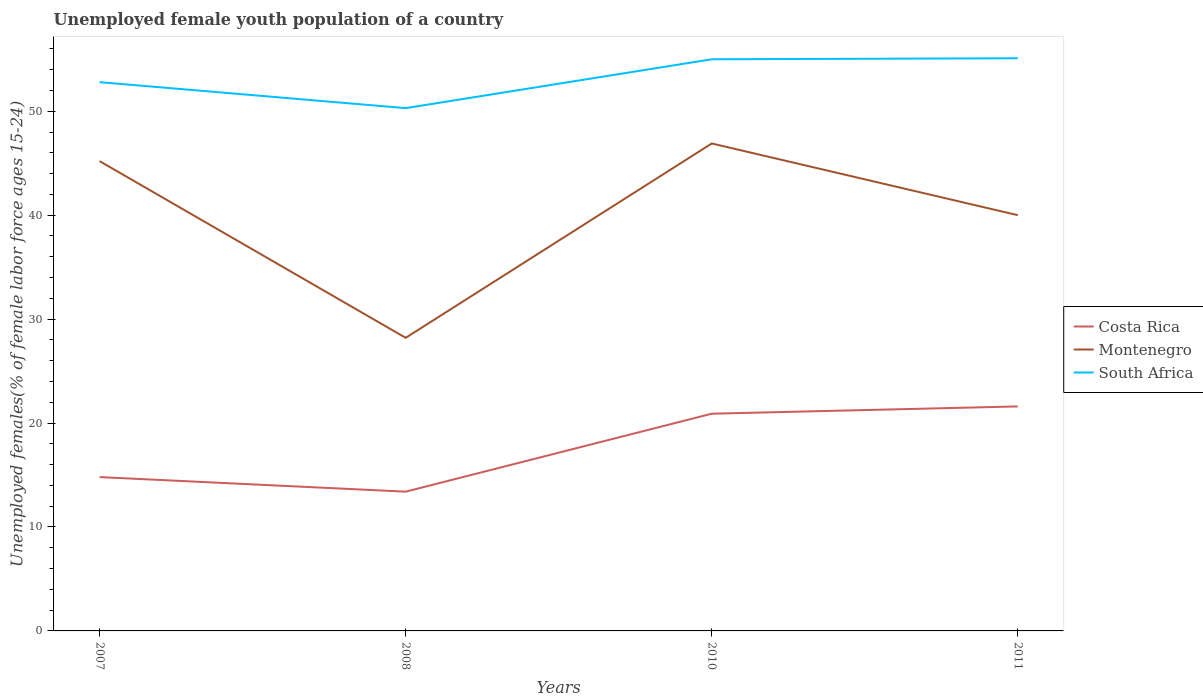Does the line corresponding to Costa Rica intersect with the line corresponding to Montenegro?
Provide a succinct answer. No. Across all years, what is the maximum percentage of unemployed female youth population in South Africa?
Your response must be concise. 50.3. What is the total percentage of unemployed female youth population in Montenegro in the graph?
Offer a terse response. 17. What is the difference between the highest and the second highest percentage of unemployed female youth population in South Africa?
Keep it short and to the point. 4.8. What is the difference between the highest and the lowest percentage of unemployed female youth population in Costa Rica?
Offer a terse response. 2. Is the percentage of unemployed female youth population in Costa Rica strictly greater than the percentage of unemployed female youth population in Montenegro over the years?
Your answer should be very brief. Yes. How many lines are there?
Offer a very short reply. 3. How many years are there in the graph?
Make the answer very short. 4. Does the graph contain any zero values?
Your response must be concise. No. Does the graph contain grids?
Offer a very short reply. No. Where does the legend appear in the graph?
Ensure brevity in your answer.  Center right. What is the title of the graph?
Your answer should be very brief. Unemployed female youth population of a country. What is the label or title of the X-axis?
Offer a terse response. Years. What is the label or title of the Y-axis?
Give a very brief answer. Unemployed females(% of female labor force ages 15-24). What is the Unemployed females(% of female labor force ages 15-24) in Costa Rica in 2007?
Your response must be concise. 14.8. What is the Unemployed females(% of female labor force ages 15-24) of Montenegro in 2007?
Ensure brevity in your answer.  45.2. What is the Unemployed females(% of female labor force ages 15-24) of South Africa in 2007?
Ensure brevity in your answer.  52.8. What is the Unemployed females(% of female labor force ages 15-24) of Costa Rica in 2008?
Ensure brevity in your answer.  13.4. What is the Unemployed females(% of female labor force ages 15-24) in Montenegro in 2008?
Keep it short and to the point. 28.2. What is the Unemployed females(% of female labor force ages 15-24) in South Africa in 2008?
Offer a terse response. 50.3. What is the Unemployed females(% of female labor force ages 15-24) in Costa Rica in 2010?
Offer a terse response. 20.9. What is the Unemployed females(% of female labor force ages 15-24) of Montenegro in 2010?
Offer a terse response. 46.9. What is the Unemployed females(% of female labor force ages 15-24) of South Africa in 2010?
Provide a succinct answer. 55. What is the Unemployed females(% of female labor force ages 15-24) in Costa Rica in 2011?
Provide a short and direct response. 21.6. What is the Unemployed females(% of female labor force ages 15-24) in South Africa in 2011?
Your answer should be compact. 55.1. Across all years, what is the maximum Unemployed females(% of female labor force ages 15-24) of Costa Rica?
Provide a short and direct response. 21.6. Across all years, what is the maximum Unemployed females(% of female labor force ages 15-24) of Montenegro?
Provide a short and direct response. 46.9. Across all years, what is the maximum Unemployed females(% of female labor force ages 15-24) of South Africa?
Provide a succinct answer. 55.1. Across all years, what is the minimum Unemployed females(% of female labor force ages 15-24) in Costa Rica?
Your answer should be very brief. 13.4. Across all years, what is the minimum Unemployed females(% of female labor force ages 15-24) of Montenegro?
Give a very brief answer. 28.2. Across all years, what is the minimum Unemployed females(% of female labor force ages 15-24) of South Africa?
Keep it short and to the point. 50.3. What is the total Unemployed females(% of female labor force ages 15-24) in Costa Rica in the graph?
Offer a terse response. 70.7. What is the total Unemployed females(% of female labor force ages 15-24) in Montenegro in the graph?
Your response must be concise. 160.3. What is the total Unemployed females(% of female labor force ages 15-24) of South Africa in the graph?
Your response must be concise. 213.2. What is the difference between the Unemployed females(% of female labor force ages 15-24) of Costa Rica in 2007 and that in 2008?
Your answer should be very brief. 1.4. What is the difference between the Unemployed females(% of female labor force ages 15-24) of Montenegro in 2007 and that in 2008?
Keep it short and to the point. 17. What is the difference between the Unemployed females(% of female labor force ages 15-24) in Montenegro in 2007 and that in 2010?
Provide a short and direct response. -1.7. What is the difference between the Unemployed females(% of female labor force ages 15-24) of South Africa in 2007 and that in 2010?
Offer a terse response. -2.2. What is the difference between the Unemployed females(% of female labor force ages 15-24) of Costa Rica in 2007 and that in 2011?
Your response must be concise. -6.8. What is the difference between the Unemployed females(% of female labor force ages 15-24) of Montenegro in 2007 and that in 2011?
Your answer should be very brief. 5.2. What is the difference between the Unemployed females(% of female labor force ages 15-24) of Montenegro in 2008 and that in 2010?
Your response must be concise. -18.7. What is the difference between the Unemployed females(% of female labor force ages 15-24) of Costa Rica in 2008 and that in 2011?
Provide a succinct answer. -8.2. What is the difference between the Unemployed females(% of female labor force ages 15-24) in Montenegro in 2008 and that in 2011?
Provide a succinct answer. -11.8. What is the difference between the Unemployed females(% of female labor force ages 15-24) in South Africa in 2008 and that in 2011?
Your response must be concise. -4.8. What is the difference between the Unemployed females(% of female labor force ages 15-24) of Costa Rica in 2010 and that in 2011?
Offer a very short reply. -0.7. What is the difference between the Unemployed females(% of female labor force ages 15-24) of South Africa in 2010 and that in 2011?
Provide a succinct answer. -0.1. What is the difference between the Unemployed females(% of female labor force ages 15-24) in Costa Rica in 2007 and the Unemployed females(% of female labor force ages 15-24) in Montenegro in 2008?
Your answer should be compact. -13.4. What is the difference between the Unemployed females(% of female labor force ages 15-24) of Costa Rica in 2007 and the Unemployed females(% of female labor force ages 15-24) of South Africa in 2008?
Your response must be concise. -35.5. What is the difference between the Unemployed females(% of female labor force ages 15-24) of Costa Rica in 2007 and the Unemployed females(% of female labor force ages 15-24) of Montenegro in 2010?
Your response must be concise. -32.1. What is the difference between the Unemployed females(% of female labor force ages 15-24) of Costa Rica in 2007 and the Unemployed females(% of female labor force ages 15-24) of South Africa in 2010?
Give a very brief answer. -40.2. What is the difference between the Unemployed females(% of female labor force ages 15-24) of Costa Rica in 2007 and the Unemployed females(% of female labor force ages 15-24) of Montenegro in 2011?
Offer a terse response. -25.2. What is the difference between the Unemployed females(% of female labor force ages 15-24) in Costa Rica in 2007 and the Unemployed females(% of female labor force ages 15-24) in South Africa in 2011?
Keep it short and to the point. -40.3. What is the difference between the Unemployed females(% of female labor force ages 15-24) of Montenegro in 2007 and the Unemployed females(% of female labor force ages 15-24) of South Africa in 2011?
Offer a very short reply. -9.9. What is the difference between the Unemployed females(% of female labor force ages 15-24) of Costa Rica in 2008 and the Unemployed females(% of female labor force ages 15-24) of Montenegro in 2010?
Offer a very short reply. -33.5. What is the difference between the Unemployed females(% of female labor force ages 15-24) of Costa Rica in 2008 and the Unemployed females(% of female labor force ages 15-24) of South Africa in 2010?
Give a very brief answer. -41.6. What is the difference between the Unemployed females(% of female labor force ages 15-24) of Montenegro in 2008 and the Unemployed females(% of female labor force ages 15-24) of South Africa in 2010?
Keep it short and to the point. -26.8. What is the difference between the Unemployed females(% of female labor force ages 15-24) of Costa Rica in 2008 and the Unemployed females(% of female labor force ages 15-24) of Montenegro in 2011?
Provide a succinct answer. -26.6. What is the difference between the Unemployed females(% of female labor force ages 15-24) in Costa Rica in 2008 and the Unemployed females(% of female labor force ages 15-24) in South Africa in 2011?
Offer a very short reply. -41.7. What is the difference between the Unemployed females(% of female labor force ages 15-24) of Montenegro in 2008 and the Unemployed females(% of female labor force ages 15-24) of South Africa in 2011?
Keep it short and to the point. -26.9. What is the difference between the Unemployed females(% of female labor force ages 15-24) in Costa Rica in 2010 and the Unemployed females(% of female labor force ages 15-24) in Montenegro in 2011?
Make the answer very short. -19.1. What is the difference between the Unemployed females(% of female labor force ages 15-24) in Costa Rica in 2010 and the Unemployed females(% of female labor force ages 15-24) in South Africa in 2011?
Give a very brief answer. -34.2. What is the difference between the Unemployed females(% of female labor force ages 15-24) of Montenegro in 2010 and the Unemployed females(% of female labor force ages 15-24) of South Africa in 2011?
Your answer should be compact. -8.2. What is the average Unemployed females(% of female labor force ages 15-24) of Costa Rica per year?
Ensure brevity in your answer.  17.68. What is the average Unemployed females(% of female labor force ages 15-24) of Montenegro per year?
Provide a short and direct response. 40.08. What is the average Unemployed females(% of female labor force ages 15-24) of South Africa per year?
Keep it short and to the point. 53.3. In the year 2007, what is the difference between the Unemployed females(% of female labor force ages 15-24) in Costa Rica and Unemployed females(% of female labor force ages 15-24) in Montenegro?
Your answer should be very brief. -30.4. In the year 2007, what is the difference between the Unemployed females(% of female labor force ages 15-24) of Costa Rica and Unemployed females(% of female labor force ages 15-24) of South Africa?
Ensure brevity in your answer.  -38. In the year 2007, what is the difference between the Unemployed females(% of female labor force ages 15-24) in Montenegro and Unemployed females(% of female labor force ages 15-24) in South Africa?
Keep it short and to the point. -7.6. In the year 2008, what is the difference between the Unemployed females(% of female labor force ages 15-24) in Costa Rica and Unemployed females(% of female labor force ages 15-24) in Montenegro?
Make the answer very short. -14.8. In the year 2008, what is the difference between the Unemployed females(% of female labor force ages 15-24) of Costa Rica and Unemployed females(% of female labor force ages 15-24) of South Africa?
Offer a terse response. -36.9. In the year 2008, what is the difference between the Unemployed females(% of female labor force ages 15-24) in Montenegro and Unemployed females(% of female labor force ages 15-24) in South Africa?
Provide a succinct answer. -22.1. In the year 2010, what is the difference between the Unemployed females(% of female labor force ages 15-24) in Costa Rica and Unemployed females(% of female labor force ages 15-24) in Montenegro?
Ensure brevity in your answer.  -26. In the year 2010, what is the difference between the Unemployed females(% of female labor force ages 15-24) of Costa Rica and Unemployed females(% of female labor force ages 15-24) of South Africa?
Offer a very short reply. -34.1. In the year 2010, what is the difference between the Unemployed females(% of female labor force ages 15-24) in Montenegro and Unemployed females(% of female labor force ages 15-24) in South Africa?
Make the answer very short. -8.1. In the year 2011, what is the difference between the Unemployed females(% of female labor force ages 15-24) in Costa Rica and Unemployed females(% of female labor force ages 15-24) in Montenegro?
Your answer should be compact. -18.4. In the year 2011, what is the difference between the Unemployed females(% of female labor force ages 15-24) in Costa Rica and Unemployed females(% of female labor force ages 15-24) in South Africa?
Your response must be concise. -33.5. In the year 2011, what is the difference between the Unemployed females(% of female labor force ages 15-24) in Montenegro and Unemployed females(% of female labor force ages 15-24) in South Africa?
Make the answer very short. -15.1. What is the ratio of the Unemployed females(% of female labor force ages 15-24) in Costa Rica in 2007 to that in 2008?
Provide a succinct answer. 1.1. What is the ratio of the Unemployed females(% of female labor force ages 15-24) in Montenegro in 2007 to that in 2008?
Make the answer very short. 1.6. What is the ratio of the Unemployed females(% of female labor force ages 15-24) in South Africa in 2007 to that in 2008?
Offer a terse response. 1.05. What is the ratio of the Unemployed females(% of female labor force ages 15-24) in Costa Rica in 2007 to that in 2010?
Provide a short and direct response. 0.71. What is the ratio of the Unemployed females(% of female labor force ages 15-24) of Montenegro in 2007 to that in 2010?
Provide a short and direct response. 0.96. What is the ratio of the Unemployed females(% of female labor force ages 15-24) in Costa Rica in 2007 to that in 2011?
Provide a succinct answer. 0.69. What is the ratio of the Unemployed females(% of female labor force ages 15-24) in Montenegro in 2007 to that in 2011?
Ensure brevity in your answer.  1.13. What is the ratio of the Unemployed females(% of female labor force ages 15-24) in Costa Rica in 2008 to that in 2010?
Your response must be concise. 0.64. What is the ratio of the Unemployed females(% of female labor force ages 15-24) of Montenegro in 2008 to that in 2010?
Make the answer very short. 0.6. What is the ratio of the Unemployed females(% of female labor force ages 15-24) of South Africa in 2008 to that in 2010?
Offer a terse response. 0.91. What is the ratio of the Unemployed females(% of female labor force ages 15-24) in Costa Rica in 2008 to that in 2011?
Offer a very short reply. 0.62. What is the ratio of the Unemployed females(% of female labor force ages 15-24) in Montenegro in 2008 to that in 2011?
Offer a very short reply. 0.7. What is the ratio of the Unemployed females(% of female labor force ages 15-24) of South Africa in 2008 to that in 2011?
Provide a short and direct response. 0.91. What is the ratio of the Unemployed females(% of female labor force ages 15-24) of Costa Rica in 2010 to that in 2011?
Give a very brief answer. 0.97. What is the ratio of the Unemployed females(% of female labor force ages 15-24) of Montenegro in 2010 to that in 2011?
Offer a terse response. 1.17. What is the difference between the highest and the second highest Unemployed females(% of female labor force ages 15-24) in Montenegro?
Your answer should be compact. 1.7. What is the difference between the highest and the second highest Unemployed females(% of female labor force ages 15-24) of South Africa?
Offer a terse response. 0.1. What is the difference between the highest and the lowest Unemployed females(% of female labor force ages 15-24) of Costa Rica?
Provide a short and direct response. 8.2. What is the difference between the highest and the lowest Unemployed females(% of female labor force ages 15-24) in Montenegro?
Provide a succinct answer. 18.7. What is the difference between the highest and the lowest Unemployed females(% of female labor force ages 15-24) of South Africa?
Your answer should be very brief. 4.8. 